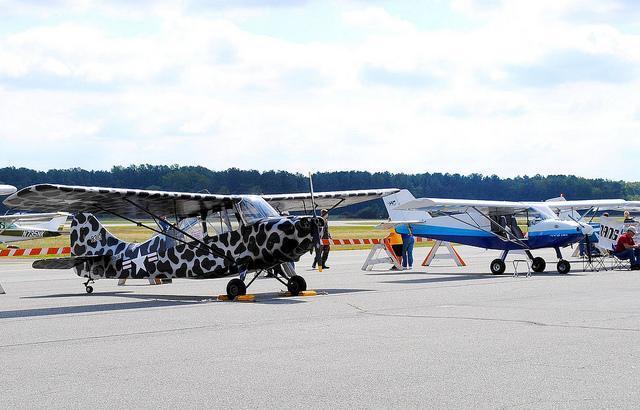How many airplanes are there?
Give a very brief answer. 2. How many brown bench seats?
Give a very brief answer. 0. 